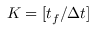Convert formula to latex. <formula><loc_0><loc_0><loc_500><loc_500>K = [ t _ { f } / \Delta t ]</formula> 